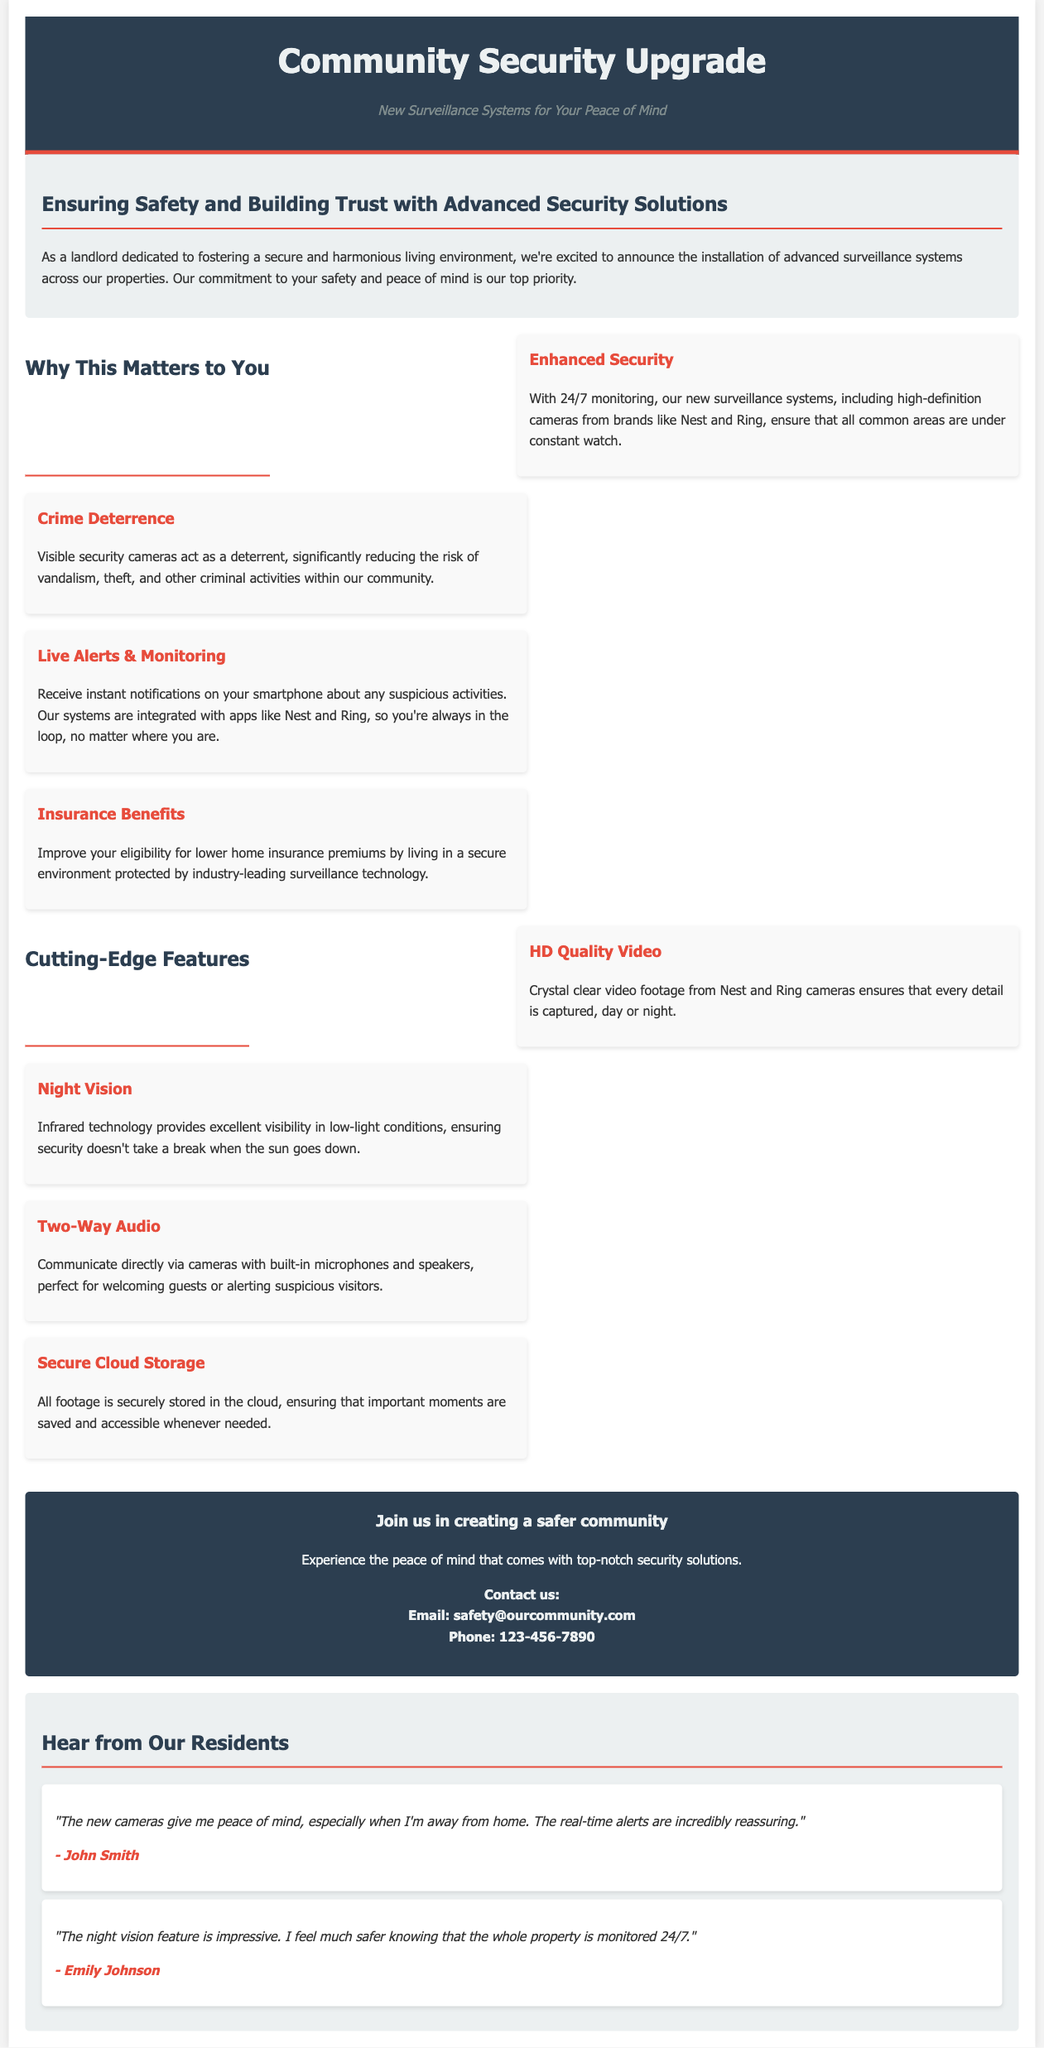What is the title of the advertisement? The title is prominently displayed at the top of the document, highlighting the main topic.
Answer: Community Security Upgrade What company is being referenced for surveillance systems? The document mentions specific brands of surveillance cameras, indicating company names that are part of the security upgrade.
Answer: Nest and Ring How many benefits are listed under "Why This Matters to You"? The document clearly separates benefits into specific items, allowing for easy counting of the listed items.
Answer: Four What feature enhances visibility in low-light conditions? The document identifies specific features of the surveillance system, highlighting their advantages.
Answer: Night Vision What is the email contact for inquiries? The contact information for the security system upgrades includes an email address specifically mentioned in the call to action section.
Answer: safety@ourcommunity.com Why should residents feel reassured about the surveillance? The document provides testimonials from residents that highlight their feelings of safety and reassurance about the implemented features.
Answer: Real-time alerts How does the surveillance system help with insurance? This aspect is discussed within the benefits, specifically stating how it impacts home insurance premiums.
Answer: Lower home insurance premiums What type of storage is used for the surveillance footage? A feature of the new system is identified in relation to how footage is managed and stored, indicating security and accessibility.
Answer: Secure Cloud Storage 